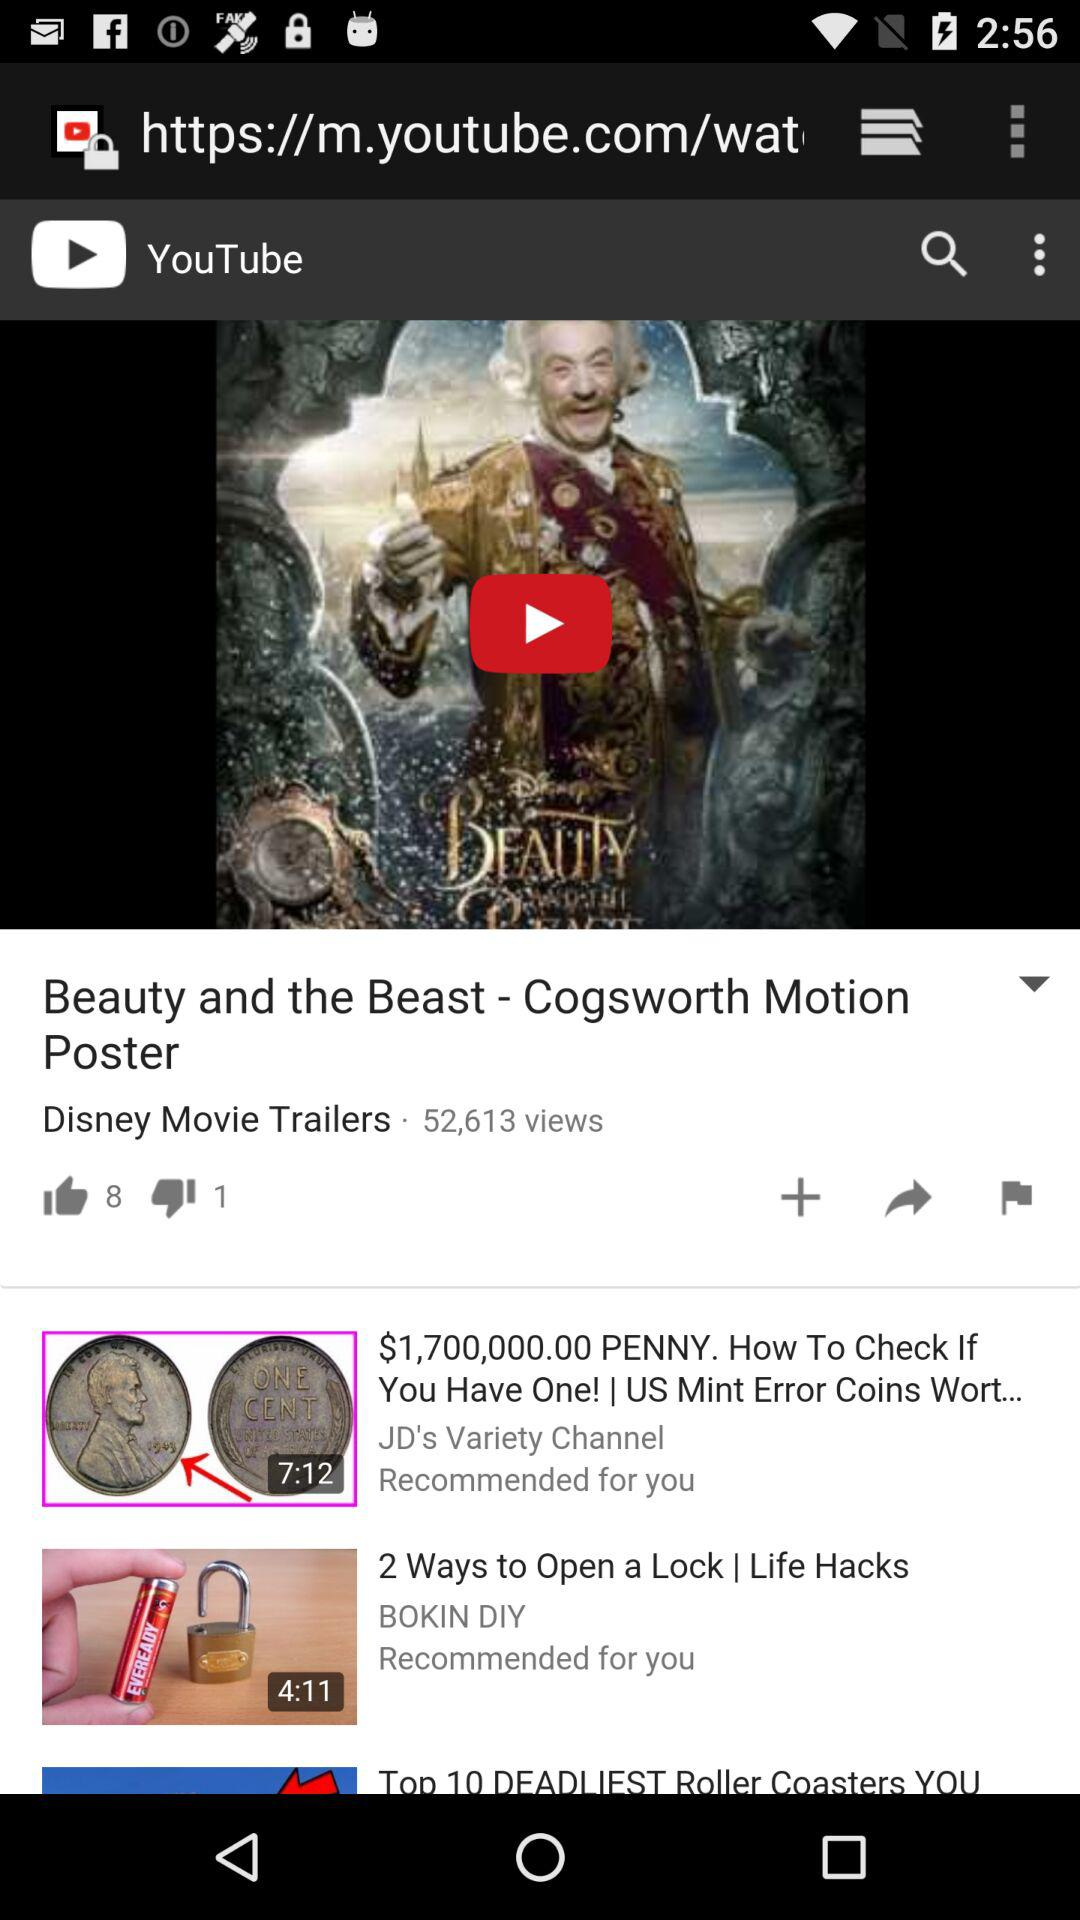What's the total count of views of the video? The total count of views is 52,613. 